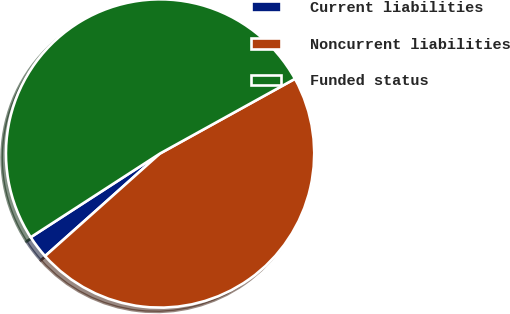Convert chart to OTSL. <chart><loc_0><loc_0><loc_500><loc_500><pie_chart><fcel>Current liabilities<fcel>Noncurrent liabilities<fcel>Funded status<nl><fcel>2.45%<fcel>46.45%<fcel>51.1%<nl></chart> 